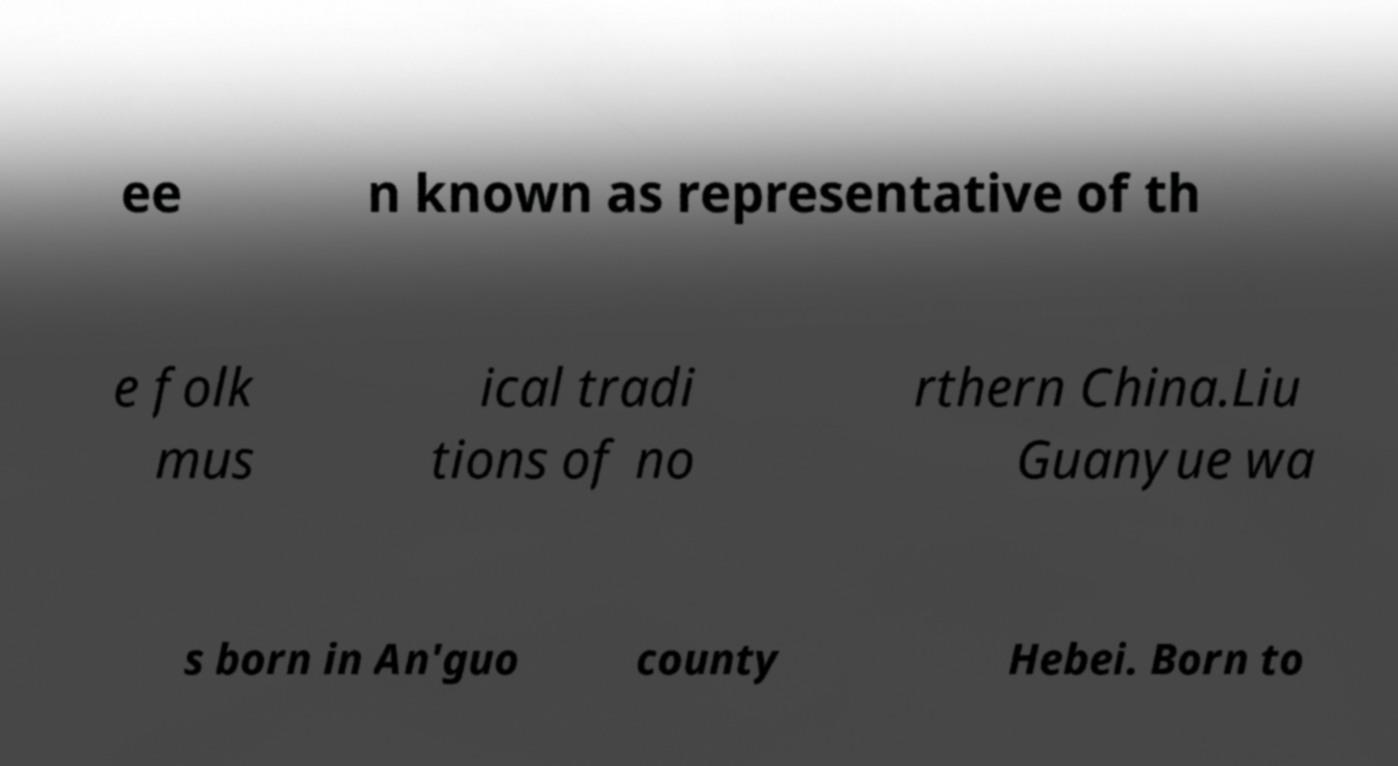What messages or text are displayed in this image? I need them in a readable, typed format. ee n known as representative of th e folk mus ical tradi tions of no rthern China.Liu Guanyue wa s born in An'guo county Hebei. Born to 